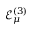Convert formula to latex. <formula><loc_0><loc_0><loc_500><loc_500>\mathcal { E } _ { \mu } ^ { ( 3 ) }</formula> 